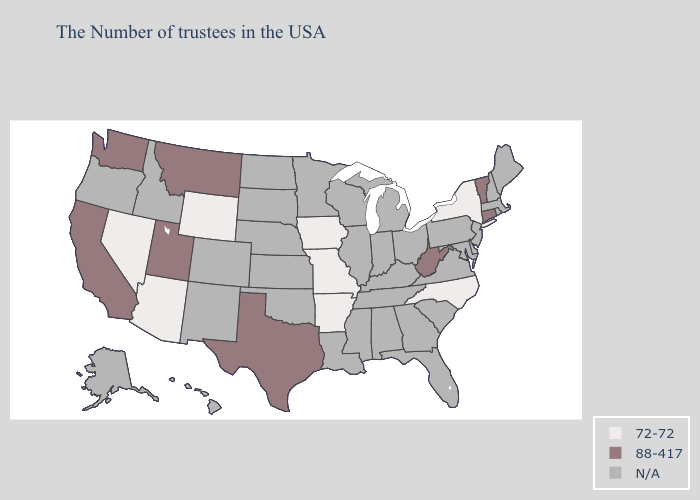Name the states that have a value in the range 88-417?
Keep it brief. Vermont, Connecticut, West Virginia, Texas, Utah, Montana, California, Washington. What is the value of Arkansas?
Write a very short answer. 72-72. What is the lowest value in states that border Montana?
Write a very short answer. 72-72. Name the states that have a value in the range 72-72?
Keep it brief. New York, North Carolina, Missouri, Arkansas, Iowa, Wyoming, Arizona, Nevada. Does Nevada have the lowest value in the West?
Quick response, please. Yes. Name the states that have a value in the range N/A?
Be succinct. Maine, Massachusetts, Rhode Island, New Hampshire, New Jersey, Delaware, Maryland, Pennsylvania, Virginia, South Carolina, Ohio, Florida, Georgia, Michigan, Kentucky, Indiana, Alabama, Tennessee, Wisconsin, Illinois, Mississippi, Louisiana, Minnesota, Kansas, Nebraska, Oklahoma, South Dakota, North Dakota, Colorado, New Mexico, Idaho, Oregon, Alaska, Hawaii. What is the value of Montana?
Keep it brief. 88-417. What is the value of Rhode Island?
Keep it brief. N/A. Does West Virginia have the lowest value in the South?
Answer briefly. No. What is the lowest value in states that border New Jersey?
Write a very short answer. 72-72. What is the value of South Carolina?
Answer briefly. N/A. What is the highest value in states that border Colorado?
Answer briefly. 88-417. What is the value of Connecticut?
Be succinct. 88-417. What is the value of Vermont?
Answer briefly. 88-417. What is the highest value in the Northeast ?
Short answer required. 88-417. 